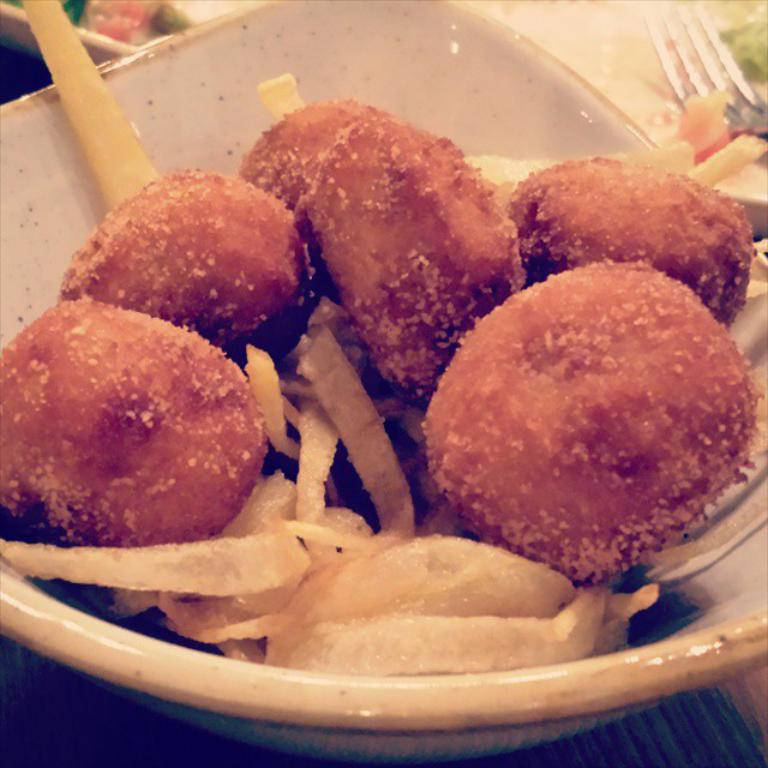What is in the bowl that is visible in the image? There is a bowl with food items in the image. Where is the bowl located in the image? The bowl is placed on a table. What utensil is visible in the image? There is a fork in the image. How many bowls can be seen in the image? There are other bowls present in the image. Who is the expert in the image? There is no expert present in the image. Where is the faucet located in the image? There is no faucet present in the image. 